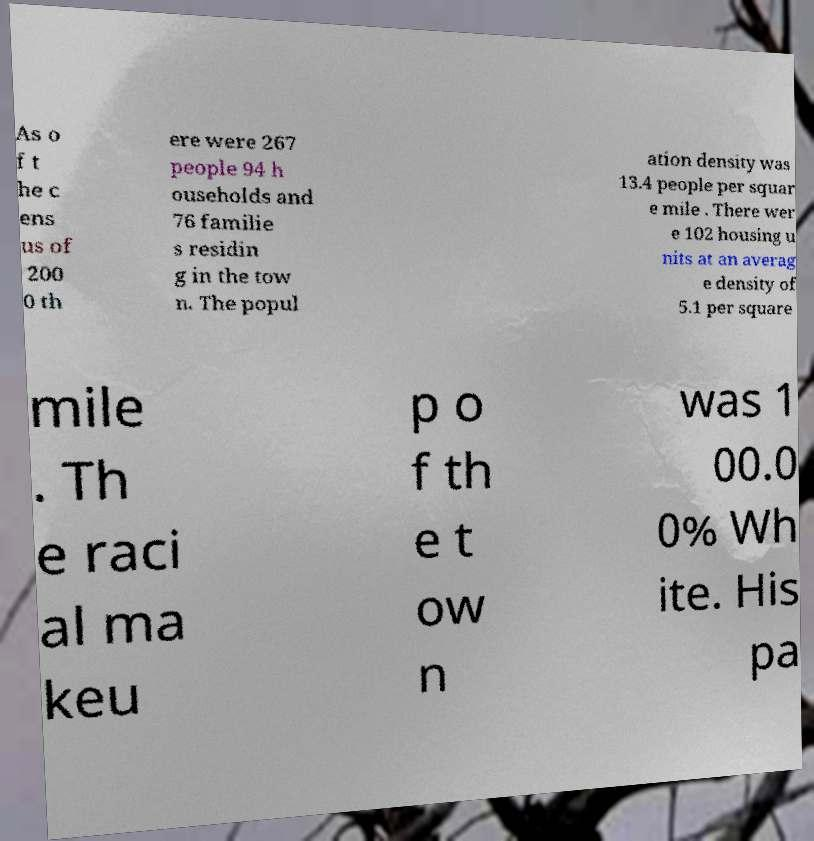Could you assist in decoding the text presented in this image and type it out clearly? As o f t he c ens us of 200 0 th ere were 267 people 94 h ouseholds and 76 familie s residin g in the tow n. The popul ation density was 13.4 people per squar e mile . There wer e 102 housing u nits at an averag e density of 5.1 per square mile . Th e raci al ma keu p o f th e t ow n was 1 00.0 0% Wh ite. His pa 